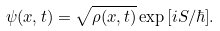<formula> <loc_0><loc_0><loc_500><loc_500>\psi ( { x } , t ) = \sqrt { \rho ( { x } , t ) } \exp { [ i S / \hbar { ] } } .</formula> 